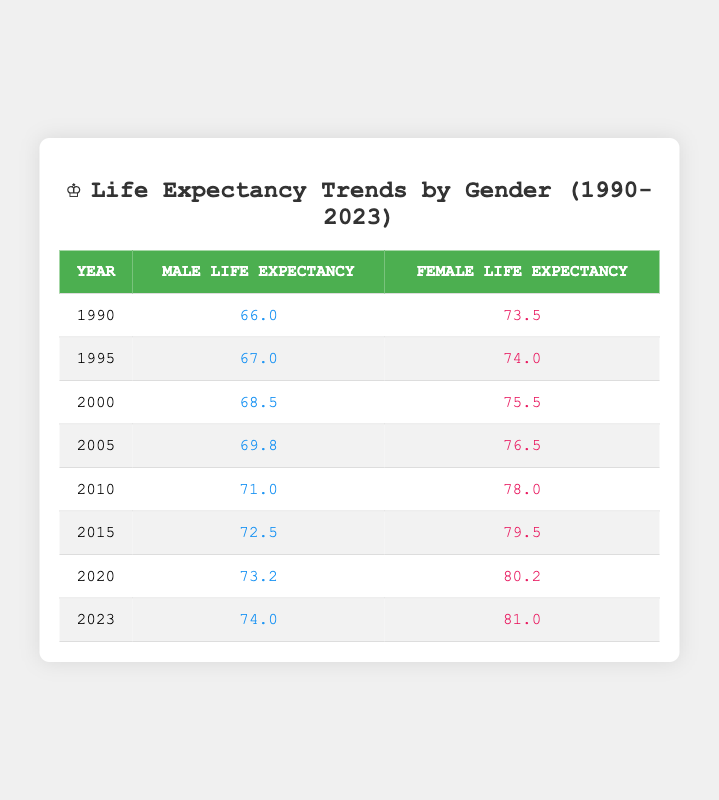What was the male life expectancy in 2000? From the table, we can look for the row corresponding to the year 2000. In that row, the male life expectancy is listed as 68.5.
Answer: 68.5 What was the female life expectancy in 1995? By examining the row for the year 1995, we find that the female life expectancy is 74.0.
Answer: 74.0 In which year did male life expectancy first exceed 70 years? By tracing the data from the table, we notice the first occurrence where male life expectancy exceeds 70 years is in 2010, where it is 71.0.
Answer: 2010 What is the difference between male and female life expectancy in 2023? In the year 2023, the male life expectancy is 74.0 and the female life expectancy is 81.0. To find the difference, we subtract: 81.0 - 74.0 = 7.0.
Answer: 7.0 Has female life expectancy consistently increased from 1990 to 2023? By observing the data, we see that female life expectancy increased from 73.5 in 1990 to 81.0 in 2023. Checking each intervening year confirms it never decreases. Thus, the statement is true.
Answer: Yes What was the average male life expectancy from 2010 to 2023? To find the average, we sum the male life expectancy from 2010 (71.0), 2015 (72.5), 2020 (73.2), and 2023 (74.0). Adding these gives 71.0 + 72.5 + 73.2 + 74.0 = 290. We have 4 values, so we divide by 4: 290 / 4 = 72.5.
Answer: 72.5 Is it true that female life expectancy in 2015 was greater than male life expectancy in 2020? From the table, female life expectancy in 2015 is 79.5, and male life expectancy in 2020 is 73.2. Comparing these values, 79.5 is indeed greater than 73.2. This makes the statement true.
Answer: Yes What was the trend in male life expectancy from 1990 to 2023? Observing the table, the male life expectancy starts at 66.0 in 1990 and trends upward to 74.0 in 2023, showing a steady increase each year without irregularity.
Answer: Increasing 